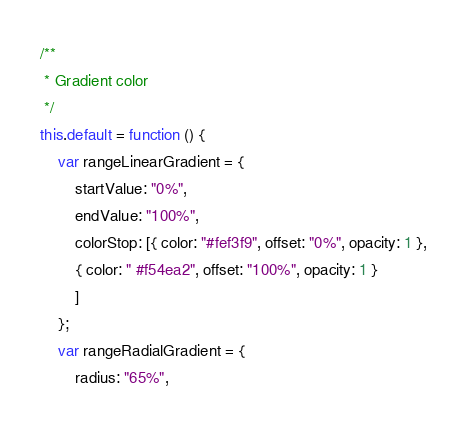<code> <loc_0><loc_0><loc_500><loc_500><_JavaScript_>/**
 * Gradient color
 */
this.default = function () {
    var rangeLinearGradient = {
        startValue: "0%",
        endValue: "100%",
        colorStop: [{ color: "#fef3f9", offset: "0%", opacity: 1 },
        { color: " #f54ea2", offset: "100%", opacity: 1 }
        ]
    };
    var rangeRadialGradient = {
        radius: "65%",</code> 